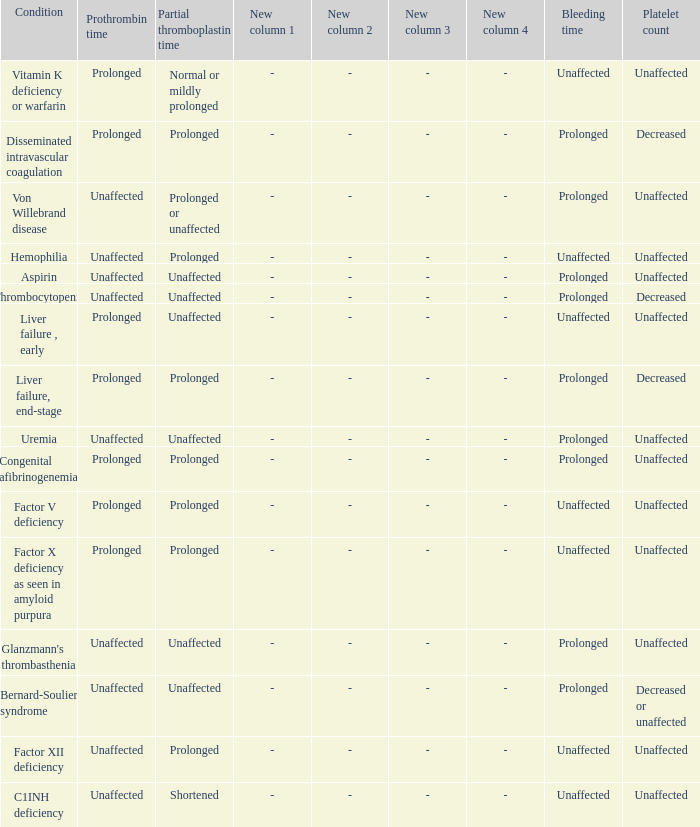In which disorder is the bleeding time normal, partial thromboplastin time extended, and prothrombin time unchanged? Hemophilia, Factor XII deficiency. 